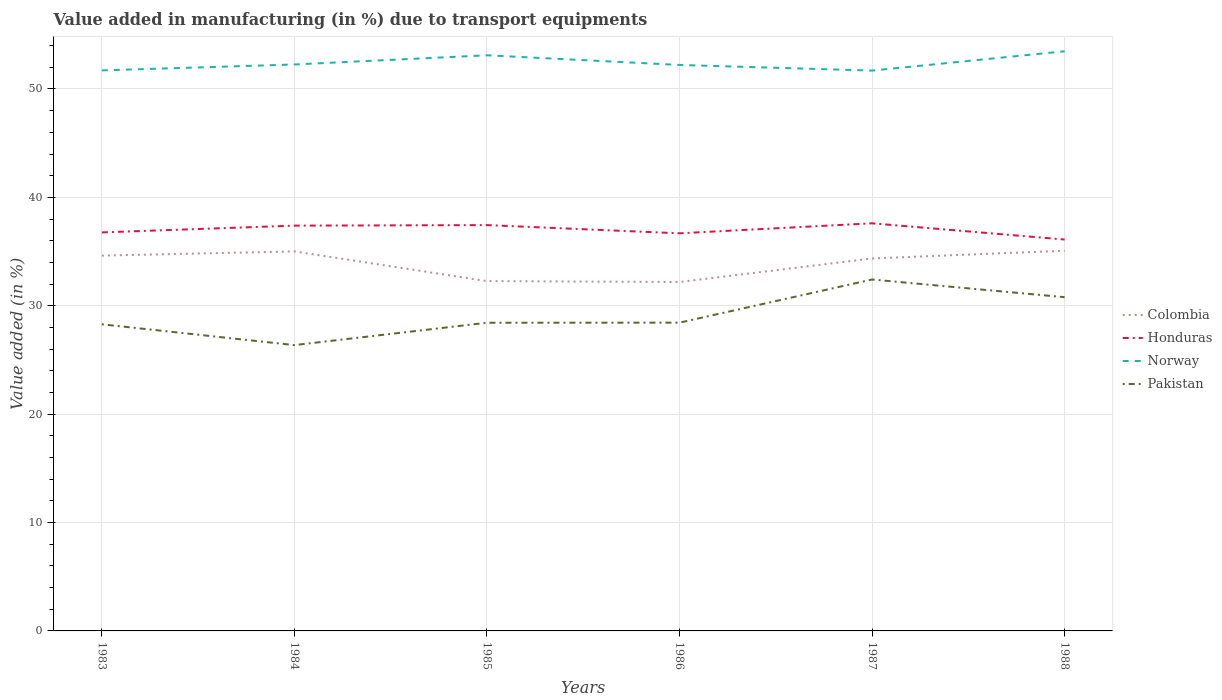How many different coloured lines are there?
Your response must be concise. 4. Is the number of lines equal to the number of legend labels?
Your response must be concise. Yes. Across all years, what is the maximum percentage of value added in manufacturing due to transport equipments in Pakistan?
Provide a short and direct response. 26.37. In which year was the percentage of value added in manufacturing due to transport equipments in Pakistan maximum?
Provide a short and direct response. 1984. What is the total percentage of value added in manufacturing due to transport equipments in Honduras in the graph?
Offer a terse response. 1.33. What is the difference between the highest and the second highest percentage of value added in manufacturing due to transport equipments in Pakistan?
Give a very brief answer. 6.05. Is the percentage of value added in manufacturing due to transport equipments in Norway strictly greater than the percentage of value added in manufacturing due to transport equipments in Honduras over the years?
Keep it short and to the point. No. How many lines are there?
Provide a succinct answer. 4. How many years are there in the graph?
Your answer should be compact. 6. What is the difference between two consecutive major ticks on the Y-axis?
Your response must be concise. 10. Does the graph contain any zero values?
Offer a very short reply. No. Does the graph contain grids?
Give a very brief answer. Yes. How many legend labels are there?
Provide a succinct answer. 4. How are the legend labels stacked?
Give a very brief answer. Vertical. What is the title of the graph?
Your answer should be very brief. Value added in manufacturing (in %) due to transport equipments. What is the label or title of the X-axis?
Provide a short and direct response. Years. What is the label or title of the Y-axis?
Keep it short and to the point. Value added (in %). What is the Value added (in %) in Colombia in 1983?
Your answer should be very brief. 34.63. What is the Value added (in %) in Honduras in 1983?
Keep it short and to the point. 36.77. What is the Value added (in %) in Norway in 1983?
Give a very brief answer. 51.72. What is the Value added (in %) of Pakistan in 1983?
Offer a terse response. 28.29. What is the Value added (in %) of Colombia in 1984?
Your response must be concise. 35.01. What is the Value added (in %) of Honduras in 1984?
Your answer should be very brief. 37.39. What is the Value added (in %) in Norway in 1984?
Your response must be concise. 52.26. What is the Value added (in %) of Pakistan in 1984?
Your answer should be compact. 26.37. What is the Value added (in %) of Colombia in 1985?
Provide a succinct answer. 32.27. What is the Value added (in %) of Honduras in 1985?
Give a very brief answer. 37.44. What is the Value added (in %) in Norway in 1985?
Offer a terse response. 53.11. What is the Value added (in %) of Pakistan in 1985?
Provide a succinct answer. 28.43. What is the Value added (in %) in Colombia in 1986?
Your response must be concise. 32.19. What is the Value added (in %) in Honduras in 1986?
Provide a succinct answer. 36.68. What is the Value added (in %) in Norway in 1986?
Provide a succinct answer. 52.22. What is the Value added (in %) in Pakistan in 1986?
Make the answer very short. 28.44. What is the Value added (in %) of Colombia in 1987?
Offer a terse response. 34.36. What is the Value added (in %) of Honduras in 1987?
Offer a terse response. 37.61. What is the Value added (in %) of Norway in 1987?
Give a very brief answer. 51.7. What is the Value added (in %) in Pakistan in 1987?
Give a very brief answer. 32.42. What is the Value added (in %) of Colombia in 1988?
Your response must be concise. 35.08. What is the Value added (in %) of Honduras in 1988?
Make the answer very short. 36.11. What is the Value added (in %) in Norway in 1988?
Keep it short and to the point. 53.48. What is the Value added (in %) in Pakistan in 1988?
Your answer should be compact. 30.79. Across all years, what is the maximum Value added (in %) in Colombia?
Make the answer very short. 35.08. Across all years, what is the maximum Value added (in %) of Honduras?
Offer a terse response. 37.61. Across all years, what is the maximum Value added (in %) of Norway?
Keep it short and to the point. 53.48. Across all years, what is the maximum Value added (in %) of Pakistan?
Offer a very short reply. 32.42. Across all years, what is the minimum Value added (in %) of Colombia?
Ensure brevity in your answer.  32.19. Across all years, what is the minimum Value added (in %) in Honduras?
Keep it short and to the point. 36.11. Across all years, what is the minimum Value added (in %) in Norway?
Keep it short and to the point. 51.7. Across all years, what is the minimum Value added (in %) of Pakistan?
Provide a short and direct response. 26.37. What is the total Value added (in %) of Colombia in the graph?
Offer a very short reply. 203.55. What is the total Value added (in %) in Honduras in the graph?
Ensure brevity in your answer.  222. What is the total Value added (in %) in Norway in the graph?
Offer a terse response. 314.48. What is the total Value added (in %) in Pakistan in the graph?
Give a very brief answer. 174.75. What is the difference between the Value added (in %) of Colombia in 1983 and that in 1984?
Your response must be concise. -0.39. What is the difference between the Value added (in %) of Honduras in 1983 and that in 1984?
Your answer should be very brief. -0.62. What is the difference between the Value added (in %) in Norway in 1983 and that in 1984?
Your answer should be very brief. -0.54. What is the difference between the Value added (in %) in Pakistan in 1983 and that in 1984?
Your response must be concise. 1.92. What is the difference between the Value added (in %) in Colombia in 1983 and that in 1985?
Give a very brief answer. 2.35. What is the difference between the Value added (in %) of Honduras in 1983 and that in 1985?
Provide a short and direct response. -0.67. What is the difference between the Value added (in %) of Norway in 1983 and that in 1985?
Make the answer very short. -1.39. What is the difference between the Value added (in %) of Pakistan in 1983 and that in 1985?
Your answer should be compact. -0.14. What is the difference between the Value added (in %) in Colombia in 1983 and that in 1986?
Provide a succinct answer. 2.43. What is the difference between the Value added (in %) of Honduras in 1983 and that in 1986?
Make the answer very short. 0.08. What is the difference between the Value added (in %) in Norway in 1983 and that in 1986?
Offer a terse response. -0.5. What is the difference between the Value added (in %) in Pakistan in 1983 and that in 1986?
Provide a short and direct response. -0.15. What is the difference between the Value added (in %) in Colombia in 1983 and that in 1987?
Keep it short and to the point. 0.26. What is the difference between the Value added (in %) of Honduras in 1983 and that in 1987?
Ensure brevity in your answer.  -0.84. What is the difference between the Value added (in %) of Norway in 1983 and that in 1987?
Your answer should be very brief. 0.02. What is the difference between the Value added (in %) of Pakistan in 1983 and that in 1987?
Provide a succinct answer. -4.13. What is the difference between the Value added (in %) of Colombia in 1983 and that in 1988?
Your answer should be compact. -0.45. What is the difference between the Value added (in %) in Honduras in 1983 and that in 1988?
Make the answer very short. 0.66. What is the difference between the Value added (in %) in Norway in 1983 and that in 1988?
Offer a very short reply. -1.76. What is the difference between the Value added (in %) in Pakistan in 1983 and that in 1988?
Provide a succinct answer. -2.5. What is the difference between the Value added (in %) of Colombia in 1984 and that in 1985?
Your answer should be compact. 2.74. What is the difference between the Value added (in %) in Honduras in 1984 and that in 1985?
Your answer should be compact. -0.05. What is the difference between the Value added (in %) of Norway in 1984 and that in 1985?
Keep it short and to the point. -0.85. What is the difference between the Value added (in %) in Pakistan in 1984 and that in 1985?
Provide a short and direct response. -2.06. What is the difference between the Value added (in %) of Colombia in 1984 and that in 1986?
Provide a short and direct response. 2.82. What is the difference between the Value added (in %) of Honduras in 1984 and that in 1986?
Give a very brief answer. 0.71. What is the difference between the Value added (in %) in Norway in 1984 and that in 1986?
Your response must be concise. 0.04. What is the difference between the Value added (in %) of Pakistan in 1984 and that in 1986?
Offer a very short reply. -2.07. What is the difference between the Value added (in %) in Colombia in 1984 and that in 1987?
Give a very brief answer. 0.65. What is the difference between the Value added (in %) in Honduras in 1984 and that in 1987?
Your answer should be compact. -0.21. What is the difference between the Value added (in %) of Norway in 1984 and that in 1987?
Offer a very short reply. 0.56. What is the difference between the Value added (in %) in Pakistan in 1984 and that in 1987?
Make the answer very short. -6.05. What is the difference between the Value added (in %) of Colombia in 1984 and that in 1988?
Your response must be concise. -0.06. What is the difference between the Value added (in %) of Honduras in 1984 and that in 1988?
Keep it short and to the point. 1.28. What is the difference between the Value added (in %) in Norway in 1984 and that in 1988?
Your response must be concise. -1.22. What is the difference between the Value added (in %) in Pakistan in 1984 and that in 1988?
Your answer should be very brief. -4.42. What is the difference between the Value added (in %) in Colombia in 1985 and that in 1986?
Ensure brevity in your answer.  0.08. What is the difference between the Value added (in %) of Honduras in 1985 and that in 1986?
Provide a succinct answer. 0.76. What is the difference between the Value added (in %) of Norway in 1985 and that in 1986?
Give a very brief answer. 0.89. What is the difference between the Value added (in %) in Pakistan in 1985 and that in 1986?
Provide a short and direct response. -0.01. What is the difference between the Value added (in %) of Colombia in 1985 and that in 1987?
Your answer should be very brief. -2.09. What is the difference between the Value added (in %) in Honduras in 1985 and that in 1987?
Offer a very short reply. -0.17. What is the difference between the Value added (in %) of Norway in 1985 and that in 1987?
Your response must be concise. 1.41. What is the difference between the Value added (in %) of Pakistan in 1985 and that in 1987?
Provide a short and direct response. -3.99. What is the difference between the Value added (in %) in Colombia in 1985 and that in 1988?
Your response must be concise. -2.8. What is the difference between the Value added (in %) of Honduras in 1985 and that in 1988?
Keep it short and to the point. 1.33. What is the difference between the Value added (in %) of Norway in 1985 and that in 1988?
Provide a succinct answer. -0.37. What is the difference between the Value added (in %) of Pakistan in 1985 and that in 1988?
Ensure brevity in your answer.  -2.36. What is the difference between the Value added (in %) of Colombia in 1986 and that in 1987?
Your answer should be compact. -2.17. What is the difference between the Value added (in %) in Honduras in 1986 and that in 1987?
Make the answer very short. -0.92. What is the difference between the Value added (in %) in Norway in 1986 and that in 1987?
Offer a terse response. 0.52. What is the difference between the Value added (in %) in Pakistan in 1986 and that in 1987?
Make the answer very short. -3.98. What is the difference between the Value added (in %) in Colombia in 1986 and that in 1988?
Keep it short and to the point. -2.89. What is the difference between the Value added (in %) in Honduras in 1986 and that in 1988?
Your answer should be compact. 0.57. What is the difference between the Value added (in %) of Norway in 1986 and that in 1988?
Make the answer very short. -1.26. What is the difference between the Value added (in %) of Pakistan in 1986 and that in 1988?
Provide a short and direct response. -2.35. What is the difference between the Value added (in %) of Colombia in 1987 and that in 1988?
Keep it short and to the point. -0.72. What is the difference between the Value added (in %) of Honduras in 1987 and that in 1988?
Ensure brevity in your answer.  1.5. What is the difference between the Value added (in %) of Norway in 1987 and that in 1988?
Your response must be concise. -1.78. What is the difference between the Value added (in %) in Pakistan in 1987 and that in 1988?
Ensure brevity in your answer.  1.63. What is the difference between the Value added (in %) in Colombia in 1983 and the Value added (in %) in Honduras in 1984?
Ensure brevity in your answer.  -2.76. What is the difference between the Value added (in %) in Colombia in 1983 and the Value added (in %) in Norway in 1984?
Your answer should be compact. -17.63. What is the difference between the Value added (in %) in Colombia in 1983 and the Value added (in %) in Pakistan in 1984?
Keep it short and to the point. 8.26. What is the difference between the Value added (in %) in Honduras in 1983 and the Value added (in %) in Norway in 1984?
Make the answer very short. -15.49. What is the difference between the Value added (in %) of Honduras in 1983 and the Value added (in %) of Pakistan in 1984?
Your answer should be compact. 10.4. What is the difference between the Value added (in %) in Norway in 1983 and the Value added (in %) in Pakistan in 1984?
Provide a short and direct response. 25.35. What is the difference between the Value added (in %) of Colombia in 1983 and the Value added (in %) of Honduras in 1985?
Your answer should be compact. -2.81. What is the difference between the Value added (in %) of Colombia in 1983 and the Value added (in %) of Norway in 1985?
Make the answer very short. -18.48. What is the difference between the Value added (in %) of Colombia in 1983 and the Value added (in %) of Pakistan in 1985?
Give a very brief answer. 6.2. What is the difference between the Value added (in %) of Honduras in 1983 and the Value added (in %) of Norway in 1985?
Your answer should be very brief. -16.34. What is the difference between the Value added (in %) of Honduras in 1983 and the Value added (in %) of Pakistan in 1985?
Offer a terse response. 8.34. What is the difference between the Value added (in %) of Norway in 1983 and the Value added (in %) of Pakistan in 1985?
Your answer should be compact. 23.28. What is the difference between the Value added (in %) of Colombia in 1983 and the Value added (in %) of Honduras in 1986?
Provide a short and direct response. -2.06. What is the difference between the Value added (in %) in Colombia in 1983 and the Value added (in %) in Norway in 1986?
Make the answer very short. -17.59. What is the difference between the Value added (in %) of Colombia in 1983 and the Value added (in %) of Pakistan in 1986?
Provide a short and direct response. 6.19. What is the difference between the Value added (in %) of Honduras in 1983 and the Value added (in %) of Norway in 1986?
Your answer should be very brief. -15.45. What is the difference between the Value added (in %) in Honduras in 1983 and the Value added (in %) in Pakistan in 1986?
Your answer should be compact. 8.33. What is the difference between the Value added (in %) in Norway in 1983 and the Value added (in %) in Pakistan in 1986?
Your response must be concise. 23.27. What is the difference between the Value added (in %) in Colombia in 1983 and the Value added (in %) in Honduras in 1987?
Ensure brevity in your answer.  -2.98. What is the difference between the Value added (in %) in Colombia in 1983 and the Value added (in %) in Norway in 1987?
Your response must be concise. -17.07. What is the difference between the Value added (in %) of Colombia in 1983 and the Value added (in %) of Pakistan in 1987?
Offer a terse response. 2.21. What is the difference between the Value added (in %) of Honduras in 1983 and the Value added (in %) of Norway in 1987?
Your answer should be compact. -14.93. What is the difference between the Value added (in %) of Honduras in 1983 and the Value added (in %) of Pakistan in 1987?
Offer a very short reply. 4.35. What is the difference between the Value added (in %) of Norway in 1983 and the Value added (in %) of Pakistan in 1987?
Provide a succinct answer. 19.29. What is the difference between the Value added (in %) of Colombia in 1983 and the Value added (in %) of Honduras in 1988?
Give a very brief answer. -1.48. What is the difference between the Value added (in %) of Colombia in 1983 and the Value added (in %) of Norway in 1988?
Your response must be concise. -18.85. What is the difference between the Value added (in %) of Colombia in 1983 and the Value added (in %) of Pakistan in 1988?
Make the answer very short. 3.84. What is the difference between the Value added (in %) in Honduras in 1983 and the Value added (in %) in Norway in 1988?
Your response must be concise. -16.71. What is the difference between the Value added (in %) of Honduras in 1983 and the Value added (in %) of Pakistan in 1988?
Keep it short and to the point. 5.98. What is the difference between the Value added (in %) of Norway in 1983 and the Value added (in %) of Pakistan in 1988?
Offer a very short reply. 20.93. What is the difference between the Value added (in %) of Colombia in 1984 and the Value added (in %) of Honduras in 1985?
Give a very brief answer. -2.43. What is the difference between the Value added (in %) in Colombia in 1984 and the Value added (in %) in Norway in 1985?
Your answer should be very brief. -18.09. What is the difference between the Value added (in %) in Colombia in 1984 and the Value added (in %) in Pakistan in 1985?
Provide a short and direct response. 6.58. What is the difference between the Value added (in %) in Honduras in 1984 and the Value added (in %) in Norway in 1985?
Give a very brief answer. -15.72. What is the difference between the Value added (in %) of Honduras in 1984 and the Value added (in %) of Pakistan in 1985?
Provide a short and direct response. 8.96. What is the difference between the Value added (in %) of Norway in 1984 and the Value added (in %) of Pakistan in 1985?
Offer a very short reply. 23.83. What is the difference between the Value added (in %) in Colombia in 1984 and the Value added (in %) in Honduras in 1986?
Provide a succinct answer. -1.67. What is the difference between the Value added (in %) of Colombia in 1984 and the Value added (in %) of Norway in 1986?
Provide a short and direct response. -17.2. What is the difference between the Value added (in %) of Colombia in 1984 and the Value added (in %) of Pakistan in 1986?
Ensure brevity in your answer.  6.57. What is the difference between the Value added (in %) in Honduras in 1984 and the Value added (in %) in Norway in 1986?
Provide a short and direct response. -14.83. What is the difference between the Value added (in %) in Honduras in 1984 and the Value added (in %) in Pakistan in 1986?
Offer a very short reply. 8.95. What is the difference between the Value added (in %) of Norway in 1984 and the Value added (in %) of Pakistan in 1986?
Give a very brief answer. 23.82. What is the difference between the Value added (in %) in Colombia in 1984 and the Value added (in %) in Honduras in 1987?
Offer a terse response. -2.59. What is the difference between the Value added (in %) in Colombia in 1984 and the Value added (in %) in Norway in 1987?
Offer a terse response. -16.68. What is the difference between the Value added (in %) in Colombia in 1984 and the Value added (in %) in Pakistan in 1987?
Keep it short and to the point. 2.59. What is the difference between the Value added (in %) in Honduras in 1984 and the Value added (in %) in Norway in 1987?
Offer a terse response. -14.3. What is the difference between the Value added (in %) of Honduras in 1984 and the Value added (in %) of Pakistan in 1987?
Make the answer very short. 4.97. What is the difference between the Value added (in %) in Norway in 1984 and the Value added (in %) in Pakistan in 1987?
Your answer should be very brief. 19.84. What is the difference between the Value added (in %) of Colombia in 1984 and the Value added (in %) of Honduras in 1988?
Offer a terse response. -1.1. What is the difference between the Value added (in %) of Colombia in 1984 and the Value added (in %) of Norway in 1988?
Provide a succinct answer. -18.47. What is the difference between the Value added (in %) of Colombia in 1984 and the Value added (in %) of Pakistan in 1988?
Keep it short and to the point. 4.22. What is the difference between the Value added (in %) of Honduras in 1984 and the Value added (in %) of Norway in 1988?
Provide a succinct answer. -16.09. What is the difference between the Value added (in %) of Honduras in 1984 and the Value added (in %) of Pakistan in 1988?
Offer a very short reply. 6.6. What is the difference between the Value added (in %) of Norway in 1984 and the Value added (in %) of Pakistan in 1988?
Make the answer very short. 21.47. What is the difference between the Value added (in %) in Colombia in 1985 and the Value added (in %) in Honduras in 1986?
Offer a very short reply. -4.41. What is the difference between the Value added (in %) in Colombia in 1985 and the Value added (in %) in Norway in 1986?
Provide a short and direct response. -19.94. What is the difference between the Value added (in %) of Colombia in 1985 and the Value added (in %) of Pakistan in 1986?
Your answer should be very brief. 3.83. What is the difference between the Value added (in %) of Honduras in 1985 and the Value added (in %) of Norway in 1986?
Your answer should be very brief. -14.78. What is the difference between the Value added (in %) in Honduras in 1985 and the Value added (in %) in Pakistan in 1986?
Offer a very short reply. 9. What is the difference between the Value added (in %) in Norway in 1985 and the Value added (in %) in Pakistan in 1986?
Offer a terse response. 24.67. What is the difference between the Value added (in %) in Colombia in 1985 and the Value added (in %) in Honduras in 1987?
Offer a very short reply. -5.33. What is the difference between the Value added (in %) in Colombia in 1985 and the Value added (in %) in Norway in 1987?
Ensure brevity in your answer.  -19.42. What is the difference between the Value added (in %) of Colombia in 1985 and the Value added (in %) of Pakistan in 1987?
Offer a very short reply. -0.15. What is the difference between the Value added (in %) of Honduras in 1985 and the Value added (in %) of Norway in 1987?
Your answer should be compact. -14.26. What is the difference between the Value added (in %) of Honduras in 1985 and the Value added (in %) of Pakistan in 1987?
Offer a very short reply. 5.02. What is the difference between the Value added (in %) in Norway in 1985 and the Value added (in %) in Pakistan in 1987?
Offer a terse response. 20.69. What is the difference between the Value added (in %) in Colombia in 1985 and the Value added (in %) in Honduras in 1988?
Provide a succinct answer. -3.84. What is the difference between the Value added (in %) in Colombia in 1985 and the Value added (in %) in Norway in 1988?
Your response must be concise. -21.2. What is the difference between the Value added (in %) in Colombia in 1985 and the Value added (in %) in Pakistan in 1988?
Your answer should be very brief. 1.48. What is the difference between the Value added (in %) of Honduras in 1985 and the Value added (in %) of Norway in 1988?
Your response must be concise. -16.04. What is the difference between the Value added (in %) of Honduras in 1985 and the Value added (in %) of Pakistan in 1988?
Your response must be concise. 6.65. What is the difference between the Value added (in %) of Norway in 1985 and the Value added (in %) of Pakistan in 1988?
Your response must be concise. 22.32. What is the difference between the Value added (in %) of Colombia in 1986 and the Value added (in %) of Honduras in 1987?
Make the answer very short. -5.41. What is the difference between the Value added (in %) of Colombia in 1986 and the Value added (in %) of Norway in 1987?
Your answer should be compact. -19.5. What is the difference between the Value added (in %) in Colombia in 1986 and the Value added (in %) in Pakistan in 1987?
Your response must be concise. -0.23. What is the difference between the Value added (in %) in Honduras in 1986 and the Value added (in %) in Norway in 1987?
Your response must be concise. -15.01. What is the difference between the Value added (in %) of Honduras in 1986 and the Value added (in %) of Pakistan in 1987?
Give a very brief answer. 4.26. What is the difference between the Value added (in %) in Norway in 1986 and the Value added (in %) in Pakistan in 1987?
Offer a terse response. 19.79. What is the difference between the Value added (in %) in Colombia in 1986 and the Value added (in %) in Honduras in 1988?
Provide a short and direct response. -3.92. What is the difference between the Value added (in %) of Colombia in 1986 and the Value added (in %) of Norway in 1988?
Offer a very short reply. -21.29. What is the difference between the Value added (in %) in Colombia in 1986 and the Value added (in %) in Pakistan in 1988?
Your response must be concise. 1.4. What is the difference between the Value added (in %) in Honduras in 1986 and the Value added (in %) in Norway in 1988?
Provide a short and direct response. -16.8. What is the difference between the Value added (in %) of Honduras in 1986 and the Value added (in %) of Pakistan in 1988?
Offer a very short reply. 5.89. What is the difference between the Value added (in %) in Norway in 1986 and the Value added (in %) in Pakistan in 1988?
Provide a short and direct response. 21.43. What is the difference between the Value added (in %) of Colombia in 1987 and the Value added (in %) of Honduras in 1988?
Keep it short and to the point. -1.75. What is the difference between the Value added (in %) of Colombia in 1987 and the Value added (in %) of Norway in 1988?
Your answer should be very brief. -19.12. What is the difference between the Value added (in %) in Colombia in 1987 and the Value added (in %) in Pakistan in 1988?
Offer a very short reply. 3.57. What is the difference between the Value added (in %) of Honduras in 1987 and the Value added (in %) of Norway in 1988?
Offer a very short reply. -15.87. What is the difference between the Value added (in %) of Honduras in 1987 and the Value added (in %) of Pakistan in 1988?
Provide a succinct answer. 6.82. What is the difference between the Value added (in %) in Norway in 1987 and the Value added (in %) in Pakistan in 1988?
Offer a terse response. 20.91. What is the average Value added (in %) in Colombia per year?
Make the answer very short. 33.92. What is the average Value added (in %) of Honduras per year?
Your answer should be compact. 37. What is the average Value added (in %) in Norway per year?
Give a very brief answer. 52.41. What is the average Value added (in %) in Pakistan per year?
Your answer should be compact. 29.12. In the year 1983, what is the difference between the Value added (in %) of Colombia and Value added (in %) of Honduras?
Offer a very short reply. -2.14. In the year 1983, what is the difference between the Value added (in %) of Colombia and Value added (in %) of Norway?
Your answer should be compact. -17.09. In the year 1983, what is the difference between the Value added (in %) of Colombia and Value added (in %) of Pakistan?
Make the answer very short. 6.34. In the year 1983, what is the difference between the Value added (in %) of Honduras and Value added (in %) of Norway?
Your response must be concise. -14.95. In the year 1983, what is the difference between the Value added (in %) of Honduras and Value added (in %) of Pakistan?
Your response must be concise. 8.48. In the year 1983, what is the difference between the Value added (in %) in Norway and Value added (in %) in Pakistan?
Your answer should be compact. 23.43. In the year 1984, what is the difference between the Value added (in %) of Colombia and Value added (in %) of Honduras?
Provide a short and direct response. -2.38. In the year 1984, what is the difference between the Value added (in %) in Colombia and Value added (in %) in Norway?
Give a very brief answer. -17.25. In the year 1984, what is the difference between the Value added (in %) in Colombia and Value added (in %) in Pakistan?
Offer a terse response. 8.64. In the year 1984, what is the difference between the Value added (in %) of Honduras and Value added (in %) of Norway?
Make the answer very short. -14.87. In the year 1984, what is the difference between the Value added (in %) in Honduras and Value added (in %) in Pakistan?
Offer a very short reply. 11.02. In the year 1984, what is the difference between the Value added (in %) of Norway and Value added (in %) of Pakistan?
Keep it short and to the point. 25.89. In the year 1985, what is the difference between the Value added (in %) of Colombia and Value added (in %) of Honduras?
Make the answer very short. -5.17. In the year 1985, what is the difference between the Value added (in %) of Colombia and Value added (in %) of Norway?
Offer a very short reply. -20.83. In the year 1985, what is the difference between the Value added (in %) of Colombia and Value added (in %) of Pakistan?
Keep it short and to the point. 3.84. In the year 1985, what is the difference between the Value added (in %) in Honduras and Value added (in %) in Norway?
Provide a short and direct response. -15.67. In the year 1985, what is the difference between the Value added (in %) in Honduras and Value added (in %) in Pakistan?
Your answer should be very brief. 9.01. In the year 1985, what is the difference between the Value added (in %) in Norway and Value added (in %) in Pakistan?
Offer a terse response. 24.68. In the year 1986, what is the difference between the Value added (in %) of Colombia and Value added (in %) of Honduras?
Offer a terse response. -4.49. In the year 1986, what is the difference between the Value added (in %) in Colombia and Value added (in %) in Norway?
Offer a terse response. -20.02. In the year 1986, what is the difference between the Value added (in %) of Colombia and Value added (in %) of Pakistan?
Your response must be concise. 3.75. In the year 1986, what is the difference between the Value added (in %) in Honduras and Value added (in %) in Norway?
Offer a very short reply. -15.53. In the year 1986, what is the difference between the Value added (in %) of Honduras and Value added (in %) of Pakistan?
Offer a very short reply. 8.24. In the year 1986, what is the difference between the Value added (in %) in Norway and Value added (in %) in Pakistan?
Your answer should be very brief. 23.78. In the year 1987, what is the difference between the Value added (in %) of Colombia and Value added (in %) of Honduras?
Keep it short and to the point. -3.24. In the year 1987, what is the difference between the Value added (in %) in Colombia and Value added (in %) in Norway?
Offer a very short reply. -17.33. In the year 1987, what is the difference between the Value added (in %) in Colombia and Value added (in %) in Pakistan?
Give a very brief answer. 1.94. In the year 1987, what is the difference between the Value added (in %) of Honduras and Value added (in %) of Norway?
Your answer should be very brief. -14.09. In the year 1987, what is the difference between the Value added (in %) in Honduras and Value added (in %) in Pakistan?
Your response must be concise. 5.18. In the year 1987, what is the difference between the Value added (in %) of Norway and Value added (in %) of Pakistan?
Your answer should be very brief. 19.27. In the year 1988, what is the difference between the Value added (in %) in Colombia and Value added (in %) in Honduras?
Your answer should be very brief. -1.03. In the year 1988, what is the difference between the Value added (in %) in Colombia and Value added (in %) in Norway?
Offer a very short reply. -18.4. In the year 1988, what is the difference between the Value added (in %) of Colombia and Value added (in %) of Pakistan?
Give a very brief answer. 4.29. In the year 1988, what is the difference between the Value added (in %) in Honduras and Value added (in %) in Norway?
Provide a short and direct response. -17.37. In the year 1988, what is the difference between the Value added (in %) in Honduras and Value added (in %) in Pakistan?
Your answer should be compact. 5.32. In the year 1988, what is the difference between the Value added (in %) of Norway and Value added (in %) of Pakistan?
Give a very brief answer. 22.69. What is the ratio of the Value added (in %) of Honduras in 1983 to that in 1984?
Provide a short and direct response. 0.98. What is the ratio of the Value added (in %) of Pakistan in 1983 to that in 1984?
Your answer should be very brief. 1.07. What is the ratio of the Value added (in %) in Colombia in 1983 to that in 1985?
Give a very brief answer. 1.07. What is the ratio of the Value added (in %) in Honduras in 1983 to that in 1985?
Offer a very short reply. 0.98. What is the ratio of the Value added (in %) in Norway in 1983 to that in 1985?
Your response must be concise. 0.97. What is the ratio of the Value added (in %) in Colombia in 1983 to that in 1986?
Your answer should be compact. 1.08. What is the ratio of the Value added (in %) in Honduras in 1983 to that in 1986?
Ensure brevity in your answer.  1. What is the ratio of the Value added (in %) in Pakistan in 1983 to that in 1986?
Provide a succinct answer. 0.99. What is the ratio of the Value added (in %) in Colombia in 1983 to that in 1987?
Provide a short and direct response. 1.01. What is the ratio of the Value added (in %) of Honduras in 1983 to that in 1987?
Your response must be concise. 0.98. What is the ratio of the Value added (in %) in Pakistan in 1983 to that in 1987?
Your response must be concise. 0.87. What is the ratio of the Value added (in %) of Colombia in 1983 to that in 1988?
Your response must be concise. 0.99. What is the ratio of the Value added (in %) in Honduras in 1983 to that in 1988?
Your answer should be compact. 1.02. What is the ratio of the Value added (in %) in Pakistan in 1983 to that in 1988?
Offer a terse response. 0.92. What is the ratio of the Value added (in %) of Colombia in 1984 to that in 1985?
Offer a terse response. 1.08. What is the ratio of the Value added (in %) in Honduras in 1984 to that in 1985?
Give a very brief answer. 1. What is the ratio of the Value added (in %) of Norway in 1984 to that in 1985?
Give a very brief answer. 0.98. What is the ratio of the Value added (in %) of Pakistan in 1984 to that in 1985?
Offer a very short reply. 0.93. What is the ratio of the Value added (in %) of Colombia in 1984 to that in 1986?
Offer a very short reply. 1.09. What is the ratio of the Value added (in %) of Honduras in 1984 to that in 1986?
Your answer should be very brief. 1.02. What is the ratio of the Value added (in %) of Pakistan in 1984 to that in 1986?
Your answer should be very brief. 0.93. What is the ratio of the Value added (in %) in Norway in 1984 to that in 1987?
Provide a succinct answer. 1.01. What is the ratio of the Value added (in %) in Pakistan in 1984 to that in 1987?
Provide a succinct answer. 0.81. What is the ratio of the Value added (in %) of Honduras in 1984 to that in 1988?
Your response must be concise. 1.04. What is the ratio of the Value added (in %) in Norway in 1984 to that in 1988?
Offer a terse response. 0.98. What is the ratio of the Value added (in %) of Pakistan in 1984 to that in 1988?
Give a very brief answer. 0.86. What is the ratio of the Value added (in %) in Honduras in 1985 to that in 1986?
Your response must be concise. 1.02. What is the ratio of the Value added (in %) in Norway in 1985 to that in 1986?
Ensure brevity in your answer.  1.02. What is the ratio of the Value added (in %) in Pakistan in 1985 to that in 1986?
Your answer should be very brief. 1. What is the ratio of the Value added (in %) of Colombia in 1985 to that in 1987?
Your answer should be compact. 0.94. What is the ratio of the Value added (in %) of Norway in 1985 to that in 1987?
Give a very brief answer. 1.03. What is the ratio of the Value added (in %) in Pakistan in 1985 to that in 1987?
Offer a terse response. 0.88. What is the ratio of the Value added (in %) in Colombia in 1985 to that in 1988?
Give a very brief answer. 0.92. What is the ratio of the Value added (in %) of Honduras in 1985 to that in 1988?
Offer a very short reply. 1.04. What is the ratio of the Value added (in %) of Pakistan in 1985 to that in 1988?
Your answer should be compact. 0.92. What is the ratio of the Value added (in %) of Colombia in 1986 to that in 1987?
Make the answer very short. 0.94. What is the ratio of the Value added (in %) in Honduras in 1986 to that in 1987?
Make the answer very short. 0.98. What is the ratio of the Value added (in %) of Pakistan in 1986 to that in 1987?
Make the answer very short. 0.88. What is the ratio of the Value added (in %) of Colombia in 1986 to that in 1988?
Provide a succinct answer. 0.92. What is the ratio of the Value added (in %) in Honduras in 1986 to that in 1988?
Ensure brevity in your answer.  1.02. What is the ratio of the Value added (in %) of Norway in 1986 to that in 1988?
Offer a very short reply. 0.98. What is the ratio of the Value added (in %) in Pakistan in 1986 to that in 1988?
Give a very brief answer. 0.92. What is the ratio of the Value added (in %) in Colombia in 1987 to that in 1988?
Your response must be concise. 0.98. What is the ratio of the Value added (in %) in Honduras in 1987 to that in 1988?
Make the answer very short. 1.04. What is the ratio of the Value added (in %) in Norway in 1987 to that in 1988?
Provide a succinct answer. 0.97. What is the ratio of the Value added (in %) in Pakistan in 1987 to that in 1988?
Your answer should be very brief. 1.05. What is the difference between the highest and the second highest Value added (in %) in Colombia?
Your answer should be very brief. 0.06. What is the difference between the highest and the second highest Value added (in %) of Honduras?
Offer a very short reply. 0.17. What is the difference between the highest and the second highest Value added (in %) in Norway?
Keep it short and to the point. 0.37. What is the difference between the highest and the second highest Value added (in %) of Pakistan?
Your answer should be compact. 1.63. What is the difference between the highest and the lowest Value added (in %) in Colombia?
Your answer should be very brief. 2.89. What is the difference between the highest and the lowest Value added (in %) of Honduras?
Provide a short and direct response. 1.5. What is the difference between the highest and the lowest Value added (in %) in Norway?
Your answer should be very brief. 1.78. What is the difference between the highest and the lowest Value added (in %) of Pakistan?
Provide a succinct answer. 6.05. 